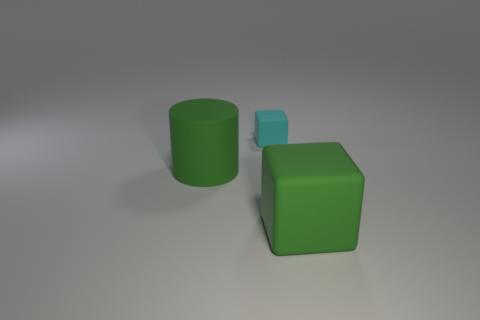There is a cyan rubber object; what shape is it?
Provide a succinct answer. Cube. What is the shape of the cyan thing that is the same material as the large block?
Ensure brevity in your answer.  Cube. There is a small cyan rubber cube; how many large things are to the right of it?
Give a very brief answer. 1. Does the rubber cube in front of the tiny cube have the same size as the matte thing that is on the left side of the small object?
Keep it short and to the point. Yes. How many other things are the same size as the cyan block?
Your answer should be compact. 0. There is a green rubber cube; is it the same size as the block that is on the left side of the green cube?
Your response must be concise. No. What is the size of the rubber thing that is right of the large green cylinder and in front of the small object?
Keep it short and to the point. Large. Is there a big object of the same color as the large cylinder?
Provide a short and direct response. Yes. What is the color of the large thing on the right side of the green object left of the small cyan thing?
Make the answer very short. Green. Is the number of matte things on the right side of the tiny cyan matte block less than the number of blocks that are to the right of the green rubber cylinder?
Give a very brief answer. Yes. 